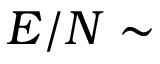<formula> <loc_0><loc_0><loc_500><loc_500>E / N \sim</formula> 